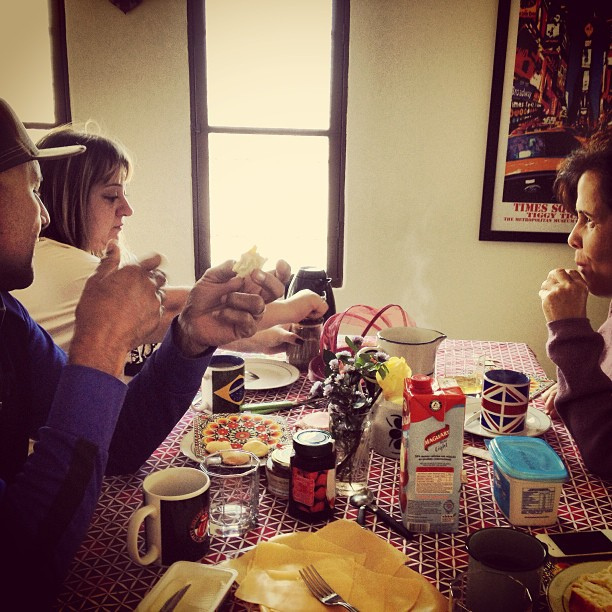<image>What type of food is inside the boxes? I don't know what type of food is inside the boxes. It could be anything from milk and tea, pasta, snacks, rice, pastry, pizza to condiments. What type of food is inside the boxes? I am not sure what type of food is inside the boxes. It can be milk and tea, pasta, snacks, rice, milk, pastry, pizza, or condiments. 